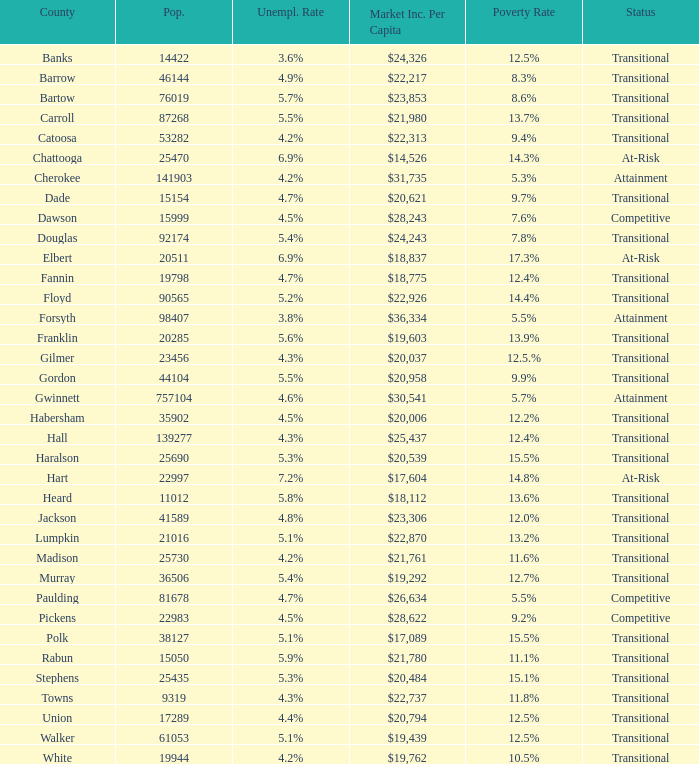Would you mind parsing the complete table? {'header': ['County', 'Pop.', 'Unempl. Rate', 'Market Inc. Per Capita', 'Poverty Rate', 'Status'], 'rows': [['Banks', '14422', '3.6%', '$24,326', '12.5%', 'Transitional'], ['Barrow', '46144', '4.9%', '$22,217', '8.3%', 'Transitional'], ['Bartow', '76019', '5.7%', '$23,853', '8.6%', 'Transitional'], ['Carroll', '87268', '5.5%', '$21,980', '13.7%', 'Transitional'], ['Catoosa', '53282', '4.2%', '$22,313', '9.4%', 'Transitional'], ['Chattooga', '25470', '6.9%', '$14,526', '14.3%', 'At-Risk'], ['Cherokee', '141903', '4.2%', '$31,735', '5.3%', 'Attainment'], ['Dade', '15154', '4.7%', '$20,621', '9.7%', 'Transitional'], ['Dawson', '15999', '4.5%', '$28,243', '7.6%', 'Competitive'], ['Douglas', '92174', '5.4%', '$24,243', '7.8%', 'Transitional'], ['Elbert', '20511', '6.9%', '$18,837', '17.3%', 'At-Risk'], ['Fannin', '19798', '4.7%', '$18,775', '12.4%', 'Transitional'], ['Floyd', '90565', '5.2%', '$22,926', '14.4%', 'Transitional'], ['Forsyth', '98407', '3.8%', '$36,334', '5.5%', 'Attainment'], ['Franklin', '20285', '5.6%', '$19,603', '13.9%', 'Transitional'], ['Gilmer', '23456', '4.3%', '$20,037', '12.5.%', 'Transitional'], ['Gordon', '44104', '5.5%', '$20,958', '9.9%', 'Transitional'], ['Gwinnett', '757104', '4.6%', '$30,541', '5.7%', 'Attainment'], ['Habersham', '35902', '4.5%', '$20,006', '12.2%', 'Transitional'], ['Hall', '139277', '4.3%', '$25,437', '12.4%', 'Transitional'], ['Haralson', '25690', '5.3%', '$20,539', '15.5%', 'Transitional'], ['Hart', '22997', '7.2%', '$17,604', '14.8%', 'At-Risk'], ['Heard', '11012', '5.8%', '$18,112', '13.6%', 'Transitional'], ['Jackson', '41589', '4.8%', '$23,306', '12.0%', 'Transitional'], ['Lumpkin', '21016', '5.1%', '$22,870', '13.2%', 'Transitional'], ['Madison', '25730', '4.2%', '$21,761', '11.6%', 'Transitional'], ['Murray', '36506', '5.4%', '$19,292', '12.7%', 'Transitional'], ['Paulding', '81678', '4.7%', '$26,634', '5.5%', 'Competitive'], ['Pickens', '22983', '4.5%', '$28,622', '9.2%', 'Competitive'], ['Polk', '38127', '5.1%', '$17,089', '15.5%', 'Transitional'], ['Rabun', '15050', '5.9%', '$21,780', '11.1%', 'Transitional'], ['Stephens', '25435', '5.3%', '$20,484', '15.1%', 'Transitional'], ['Towns', '9319', '4.3%', '$22,737', '11.8%', 'Transitional'], ['Union', '17289', '4.4%', '$20,794', '12.5%', 'Transitional'], ['Walker', '61053', '5.1%', '$19,439', '12.5%', 'Transitional'], ['White', '19944', '4.2%', '$19,762', '10.5%', 'Transitional']]} What is the per capita market income for the county with a $22,313. 